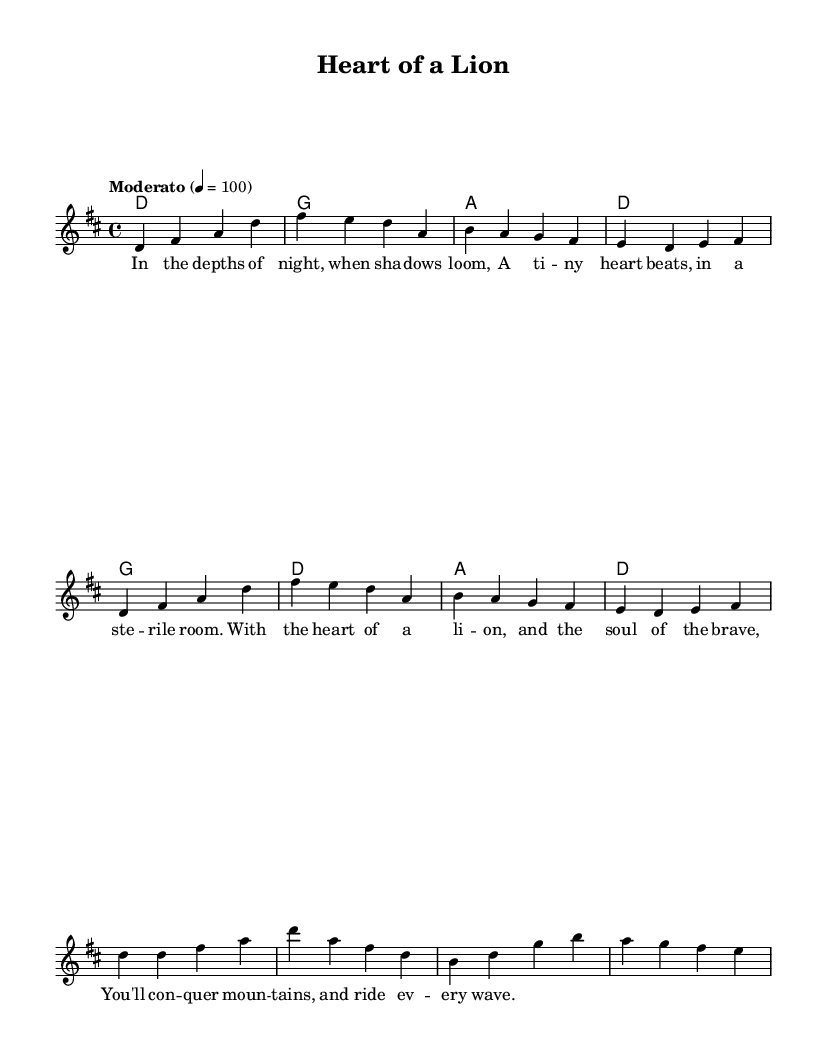What is the key signature of this music? The key signature is indicated by the initial symbols at the beginning of the music. In this case, there are two sharps (F# and C#), which corresponds to D major.
Answer: D major What is the time signature of this music? The time signature is found at the beginning of the piece and shows how the beats are organized. Here, the time signature is 4/4, indicating four beats per measure.
Answer: 4/4 What is the tempo marking of this music? The tempo marking is specified above the staff and indicates the speed of the piece. In this case, it says "Moderato" and the beats per minute (BPM) is set to 100.
Answer: Moderato How many measures are in the verse section? To find this, we count the measures specifically labeled as "verse." The verse as shown contains four measures.
Answer: Four Which instruments are indicated in this score? The score shows a voice for the melody and chord names for harmonies. There are no other instruments explicitly mentioned. Therefore, the depicted instrument group is for voice and chords.
Answer: Voice and chords What is the first lyric line of the song? The lyrics are listed below the notes of the melody. The first line of the verse reads: "In the depths of night, when shadows loom." This line is found at the beginning of the verse section.
Answer: In the depths of night, when shadows loom What does the chorus express about courage? To answer this, we look at the specific lyrics of the chorus, which discusses overcoming challenges with bravery. It states: "With the heart of a lion, and the soul of the brave." This reflects the core theme of courage.
Answer: Heart of a lion, soul of the brave 